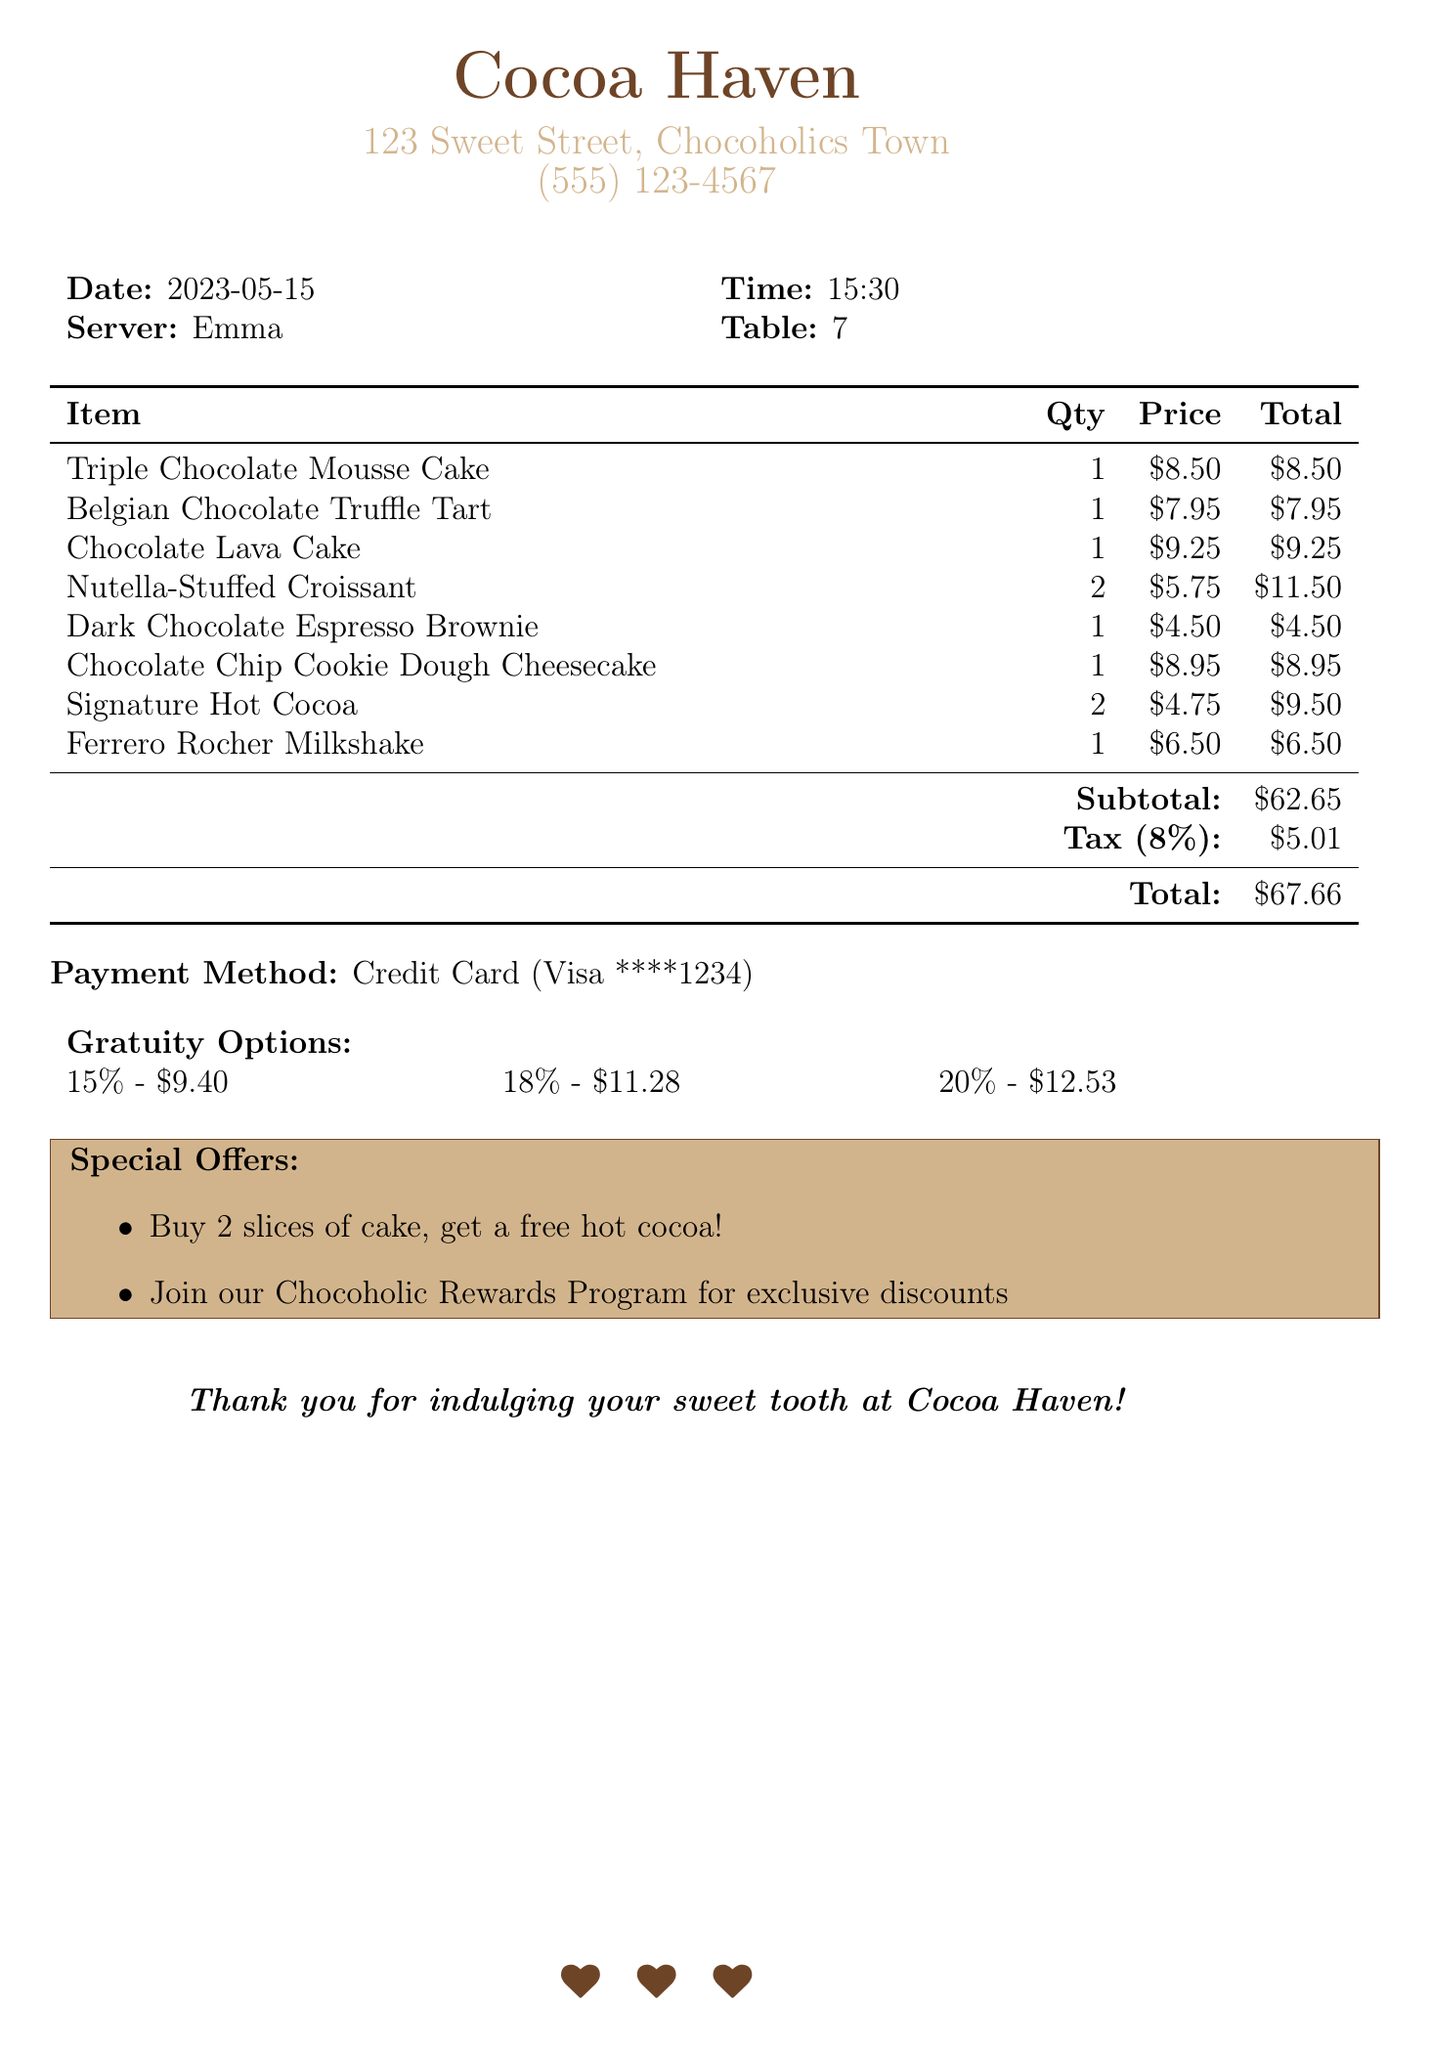What is the date of the receipt? The date of the receipt is specified in the document as the date when the purchase occurred.
Answer: 2023-05-15 What is the name of the cafe? The name of the cafe is prominently displayed at the top of the receipt, indicating where the transaction took place.
Answer: Cocoa Haven How many Nutella-Stuffed Croissants were ordered? The quantity of the Nutella-Stuffed Croissants is listed next to the item in the receipt's itemized list.
Answer: 2 What is the total amount after tax? The total amount includes the subtotal and the tax amount from the receipt, providing the final amount due.
Answer: $67.66 What payment method was used? The payment method is indicated on the receipt, showing how the customer paid for their order.
Answer: Credit Card What is the subtotal before tax? The subtotal is calculated as the sum of all item prices before any tax is applied, which is explicitly stated in the receipt.
Answer: $62.65 Which item had the highest price? The item with the highest price is listed in the itemized section of the receipt and refers to the most expensive dessert ordered.
Answer: Chocolate Lava Cake If a customer buys two slices of cake, what do they get for free? The special offer related to cake purchases indicates a promotional item given free with a specific purchase.
Answer: Hot cocoa How much is the 20% gratuity amount? The gratuity options section outlines various percentages and the corresponding amounts, including the 20% option.
Answer: $12.53 